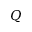<formula> <loc_0><loc_0><loc_500><loc_500>Q</formula> 